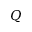<formula> <loc_0><loc_0><loc_500><loc_500>Q</formula> 